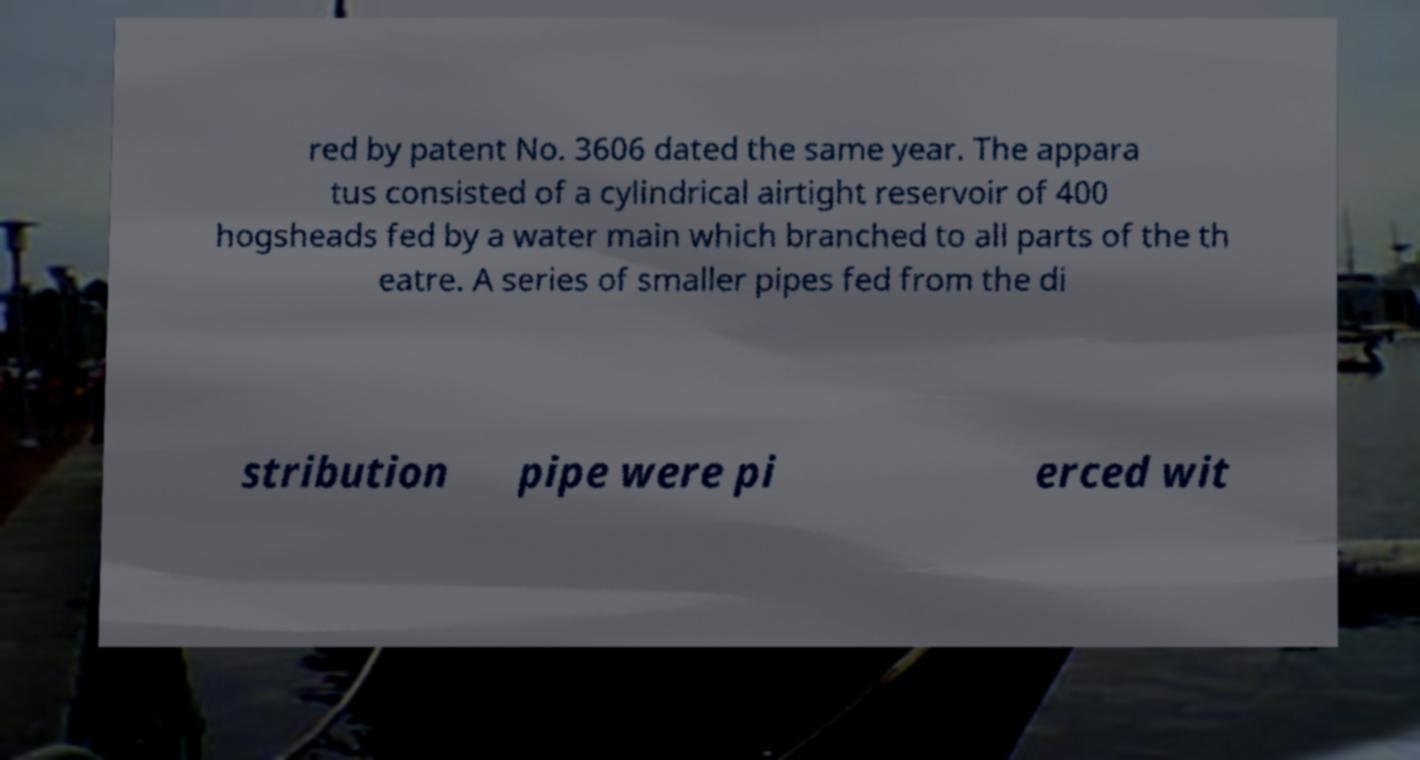Could you assist in decoding the text presented in this image and type it out clearly? red by patent No. 3606 dated the same year. The appara tus consisted of a cylindrical airtight reservoir of 400 hogsheads fed by a water main which branched to all parts of the th eatre. A series of smaller pipes fed from the di stribution pipe were pi erced wit 